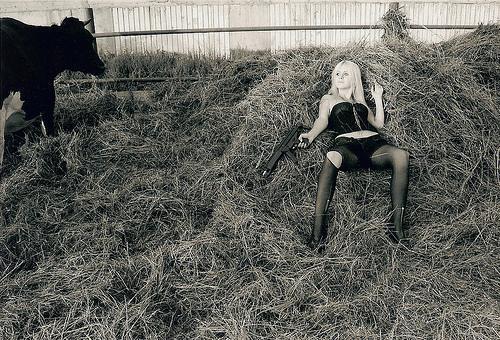How many cows are there?
Give a very brief answer. 1. 